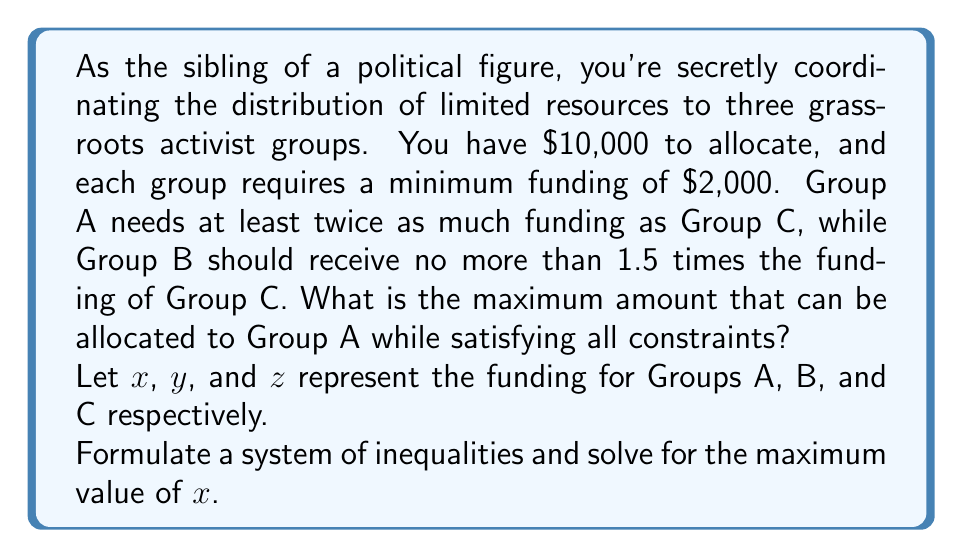Could you help me with this problem? 1) First, let's set up our system of inequalities based on the given constraints:

   $x + y + z \leq 10000$ (total budget constraint)
   $x \geq 2000$, $y \geq 2000$, $z \geq 2000$ (minimum funding for each group)
   $x \geq 2z$ (Group A needs at least twice as much as Group C)
   $y \leq 1.5z$ (Group B should receive no more than 1.5 times Group C)

2) We want to maximize $x$, so we'll assume the total budget is fully used:
   $x + y + z = 10000$

3) From the constraint $y \leq 1.5z$, we know that $y$ will be at its maximum when $y = 1.5z$

4) Substituting this into our budget equation:
   $x + 1.5z + z = 10000$
   $x + 2.5z = 10000$

5) We also know that $x \geq 2z$. To maximize $x$, we'll use equality:
   $x = 2z$

6) Substituting this into our equation from step 4:
   $2z + 2.5z = 10000$
   $4.5z = 10000$
   $z = \frac{10000}{4.5} \approx 2222.22$

7) Since $z$ must be at least 2000, this satisfies our constraint.

8) Now we can calculate the maximum value of $x$:
   $x = 2z = 2 * \frac{10000}{4.5} \approx 4444.44$

9) Rounding down to ensure we don't exceed the budget:
   $x = 4444$
Answer: $4444 